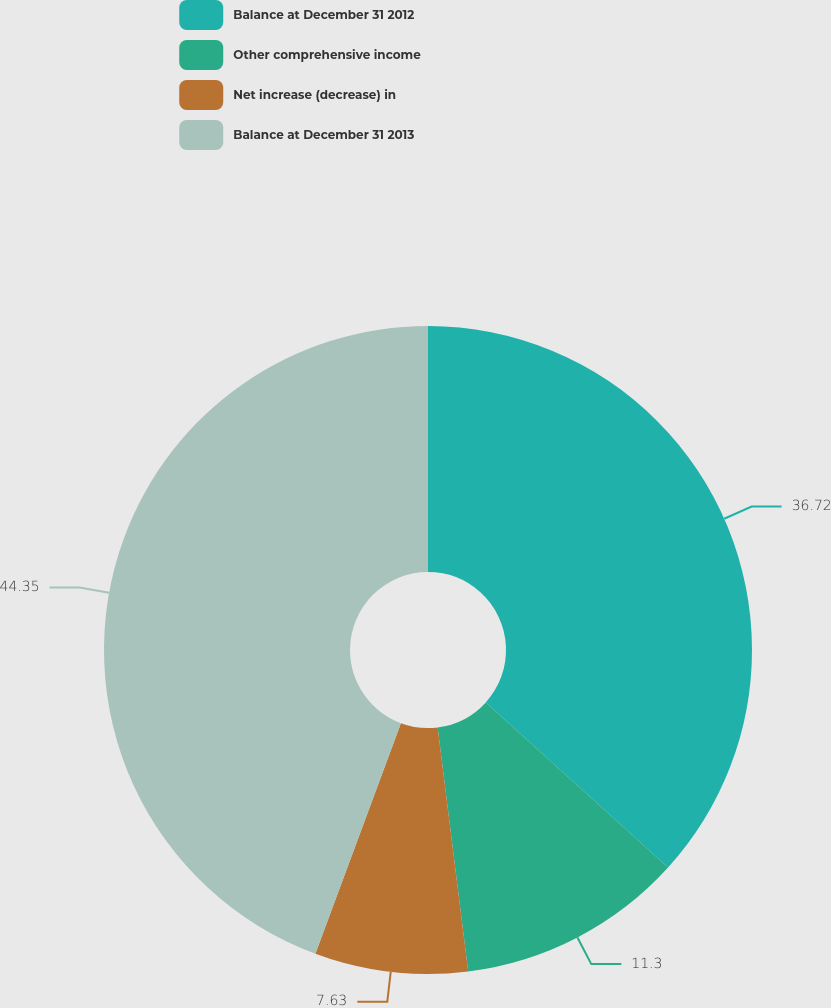Convert chart to OTSL. <chart><loc_0><loc_0><loc_500><loc_500><pie_chart><fcel>Balance at December 31 2012<fcel>Other comprehensive income<fcel>Net increase (decrease) in<fcel>Balance at December 31 2013<nl><fcel>36.72%<fcel>11.3%<fcel>7.63%<fcel>44.35%<nl></chart> 